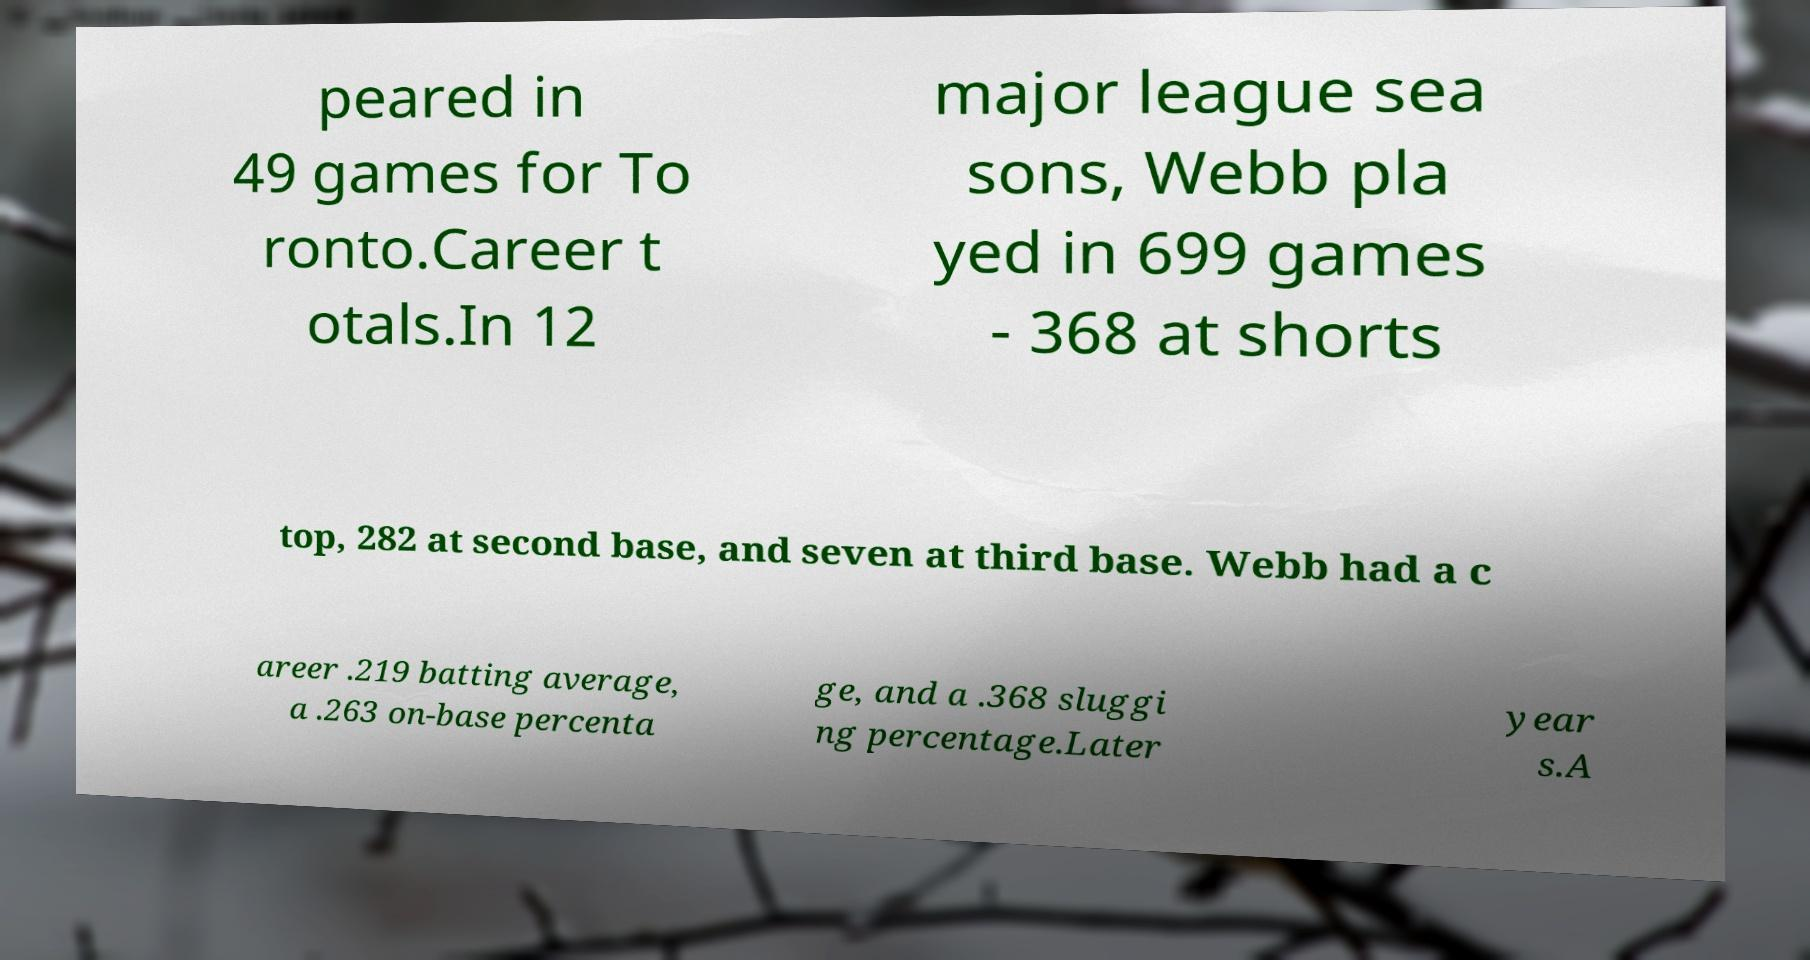Please identify and transcribe the text found in this image. peared in 49 games for To ronto.Career t otals.In 12 major league sea sons, Webb pla yed in 699 games - 368 at shorts top, 282 at second base, and seven at third base. Webb had a c areer .219 batting average, a .263 on-base percenta ge, and a .368 sluggi ng percentage.Later year s.A 